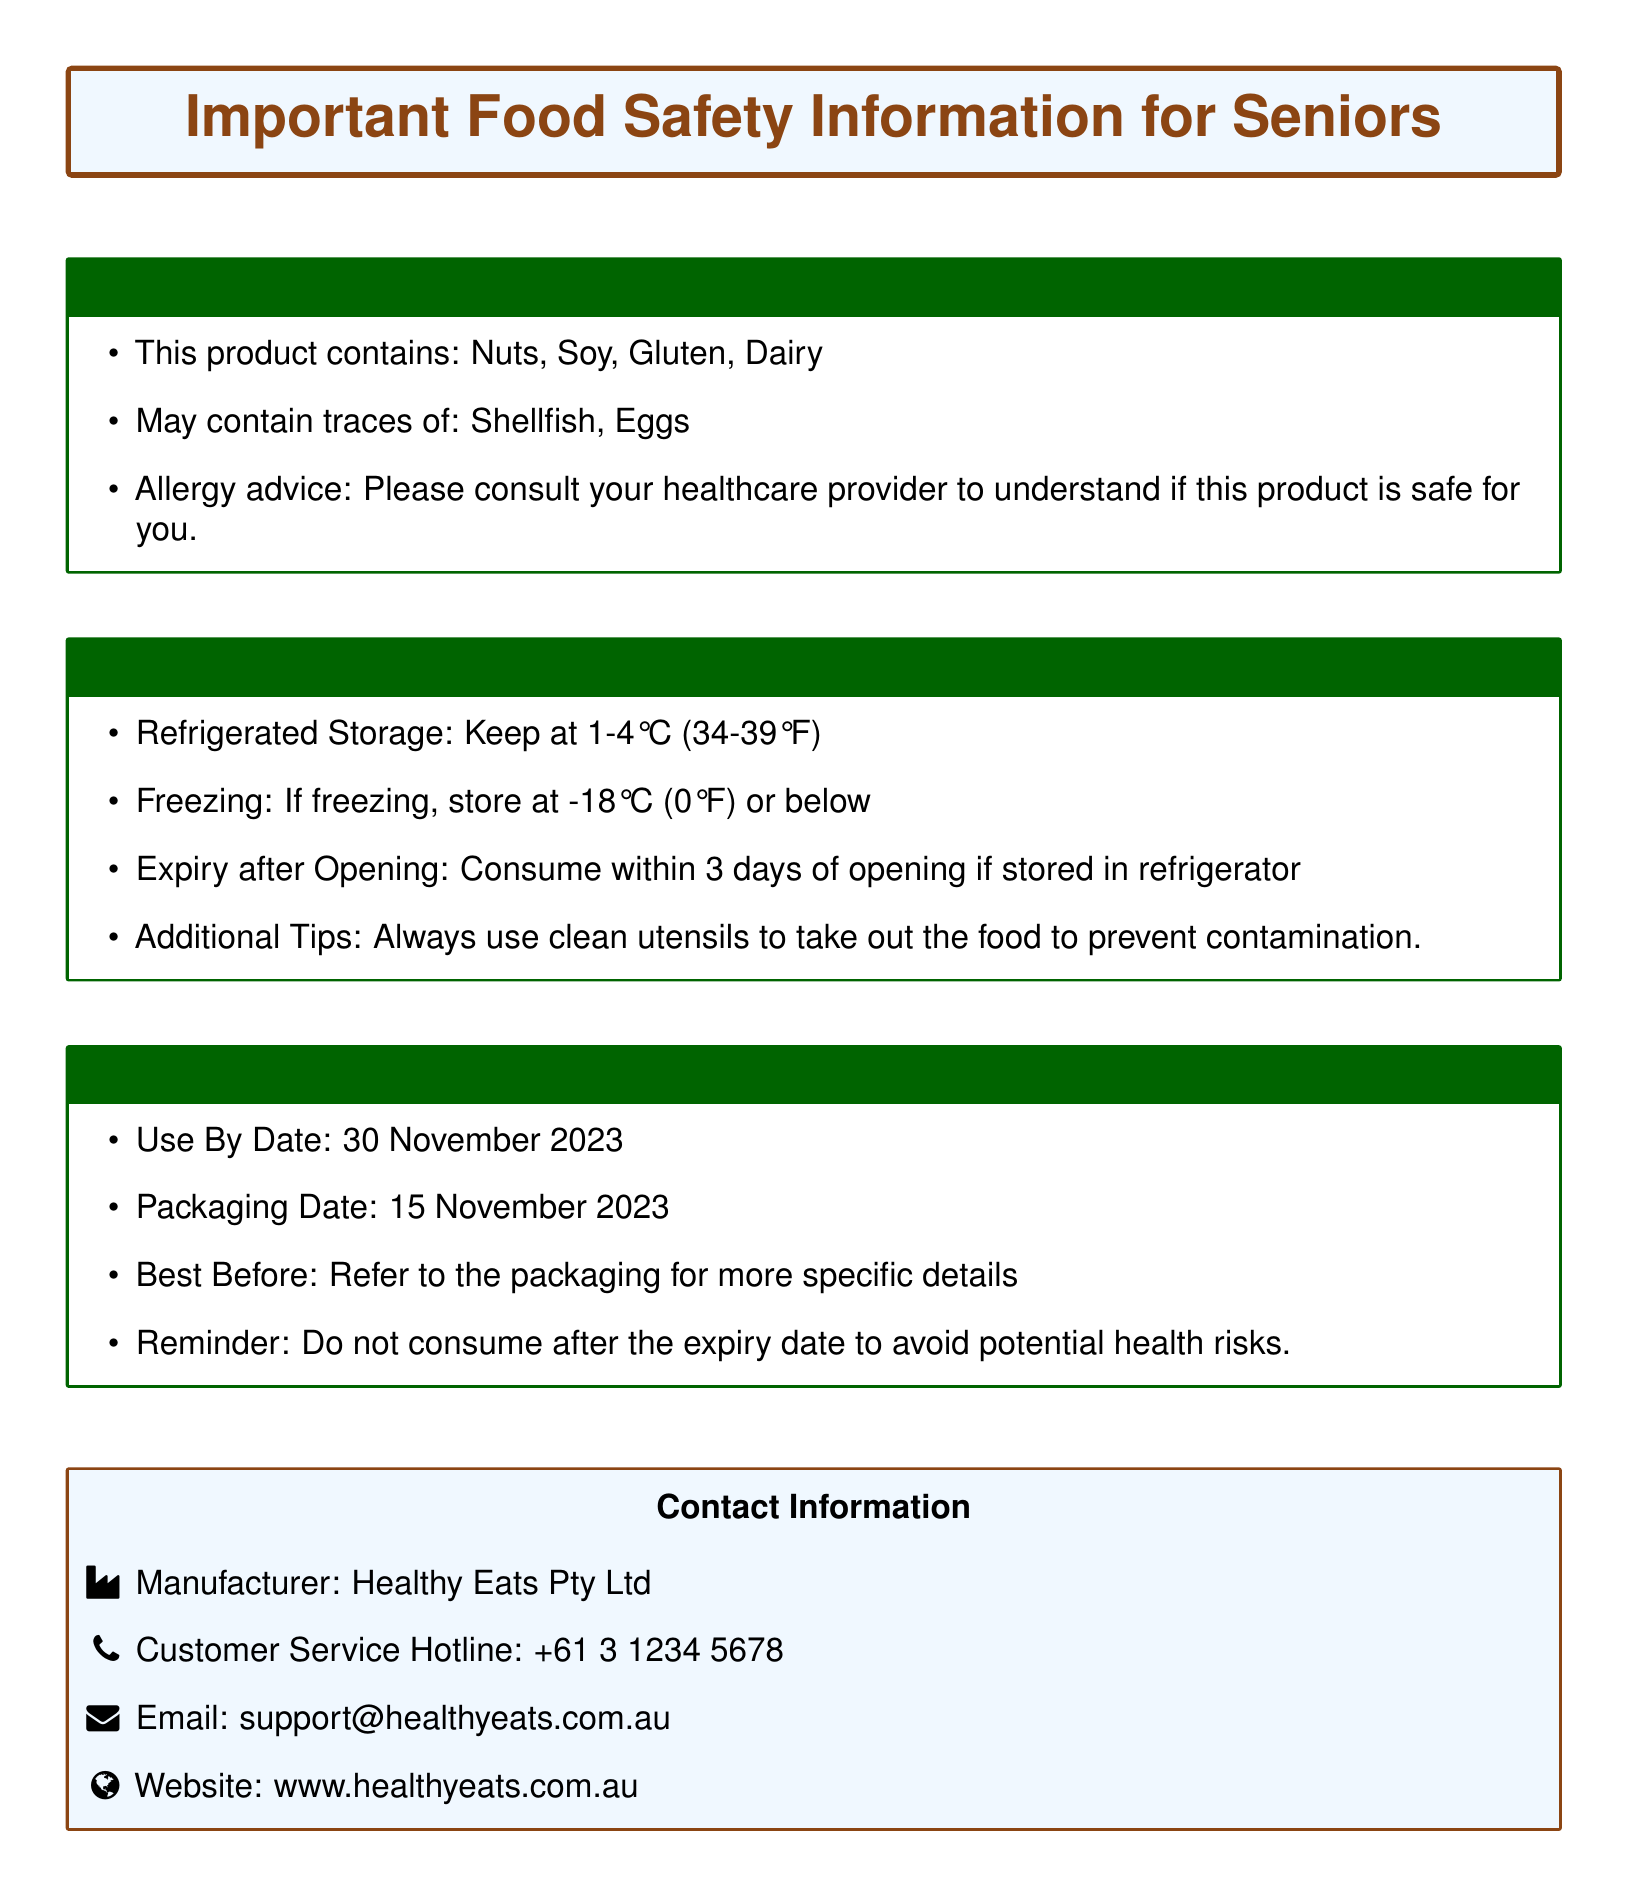What are the allergens listed? The document lists the allergens contained in the product, which are specified in the Allergy Information section.
Answer: Nuts, Soy, Gluten, Dairy What is the expiry date of the product? The document provides a Use By Date under the Expiry Date Information section.
Answer: 30 November 2023 How long should the product be consumed after opening? The Storage Conditions section states how long the product is safe to consume after it has been opened.
Answer: 3 days What temperature should the product be refrigerated at? The Storage Conditions section indicates the proper refrigerated storage temperature for the product.
Answer: 1-4°C (34-39°F) Who is the manufacturer of the product? The document provides the manufacturer's name in the Contact Information section.
Answer: Healthy Eats Pty Ltd Why is it important to consult a healthcare provider regarding this product? The Allergy Information section suggests consulting a healthcare provider for allergy safety assessment.
Answer: To understand if this product is safe for you What should be done to prevent contamination? The Storage Conditions section advises on practices to prevent contamination when handling the food.
Answer: Use clean utensils What date was the product packaged? The Expiry Date Information section provides the date when the product was packaged.
Answer: 15 November 2023 